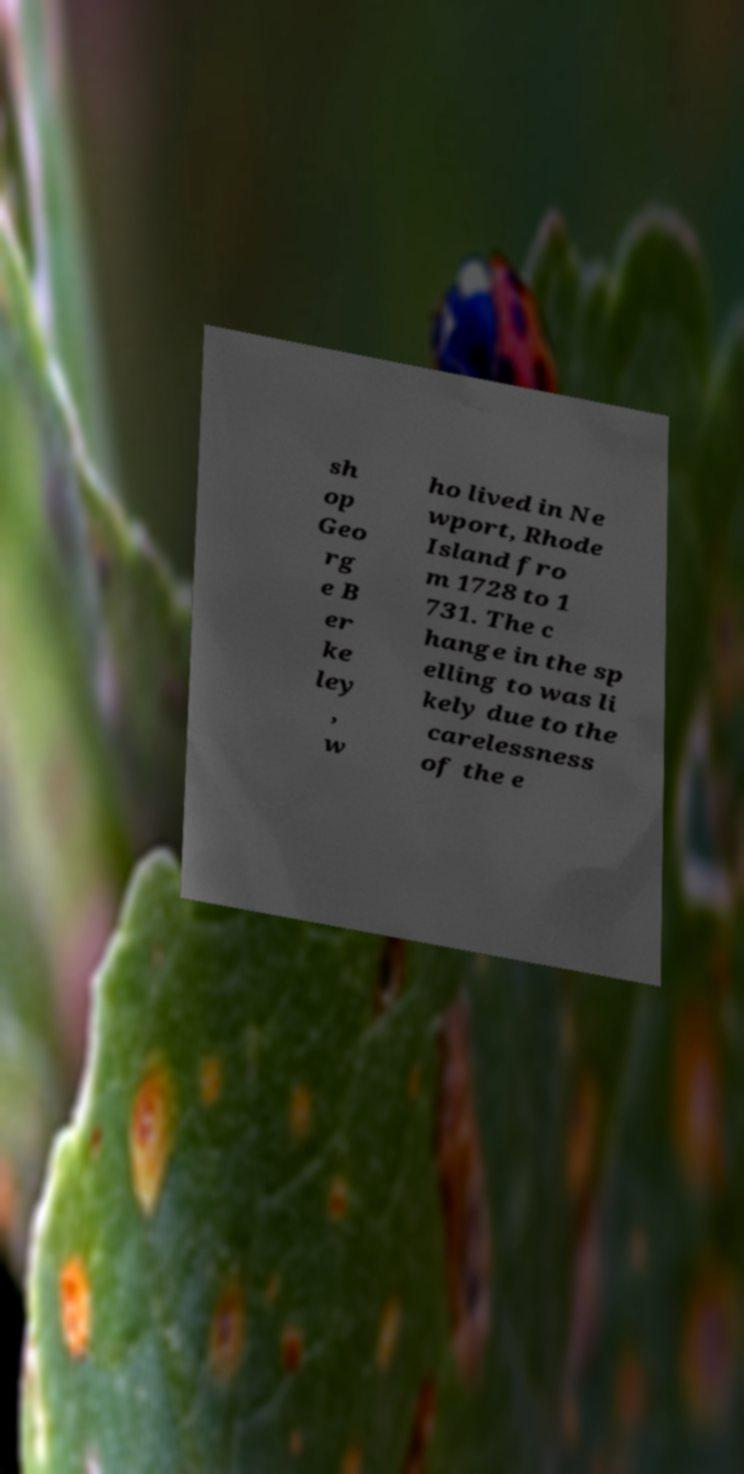Please read and relay the text visible in this image. What does it say? sh op Geo rg e B er ke ley , w ho lived in Ne wport, Rhode Island fro m 1728 to 1 731. The c hange in the sp elling to was li kely due to the carelessness of the e 